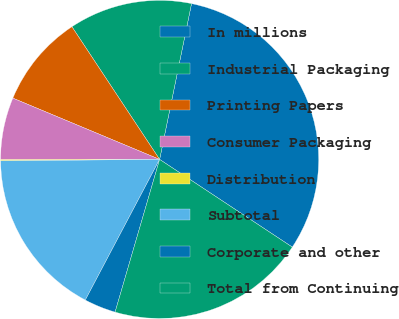Convert chart to OTSL. <chart><loc_0><loc_0><loc_500><loc_500><pie_chart><fcel>In millions<fcel>Industrial Packaging<fcel>Printing Papers<fcel>Consumer Packaging<fcel>Distribution<fcel>Subtotal<fcel>Corporate and other<fcel>Total from Continuing<nl><fcel>31.08%<fcel>12.51%<fcel>9.41%<fcel>6.32%<fcel>0.12%<fcel>17.12%<fcel>3.22%<fcel>20.22%<nl></chart> 